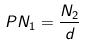<formula> <loc_0><loc_0><loc_500><loc_500>P N _ { 1 } = \frac { N _ { 2 } } { d }</formula> 